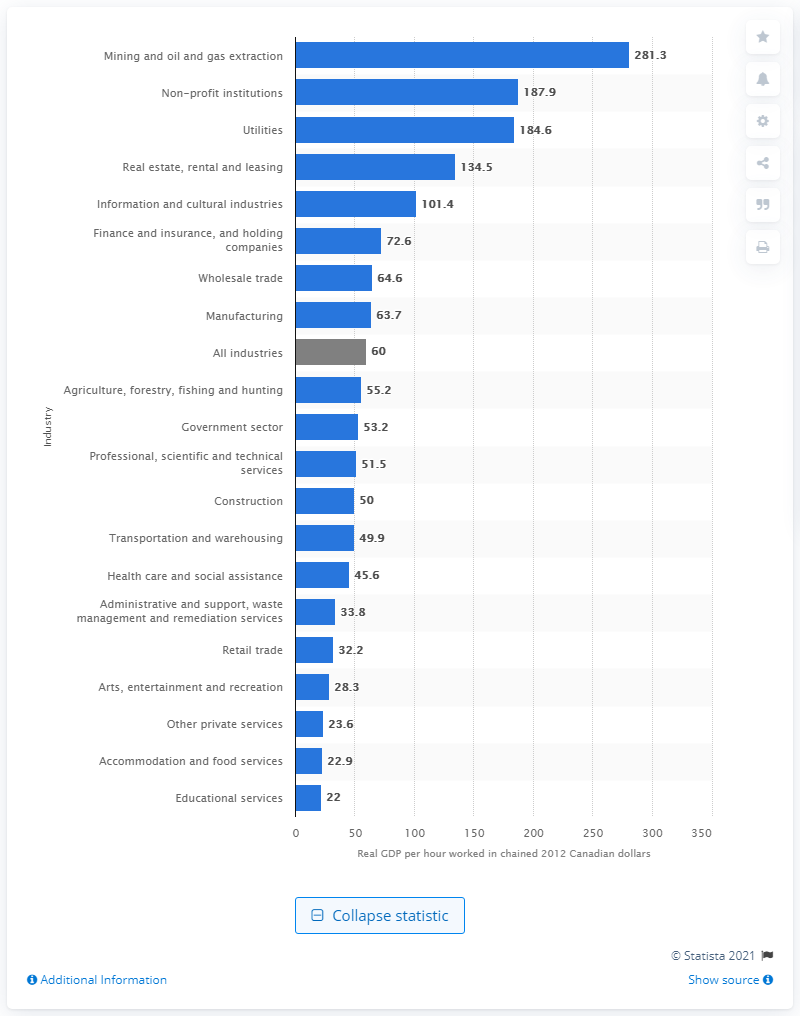Point out several critical features in this image. In 2019, the labor productivity in mining and oil and gas extraction in Canada was 281.3. 